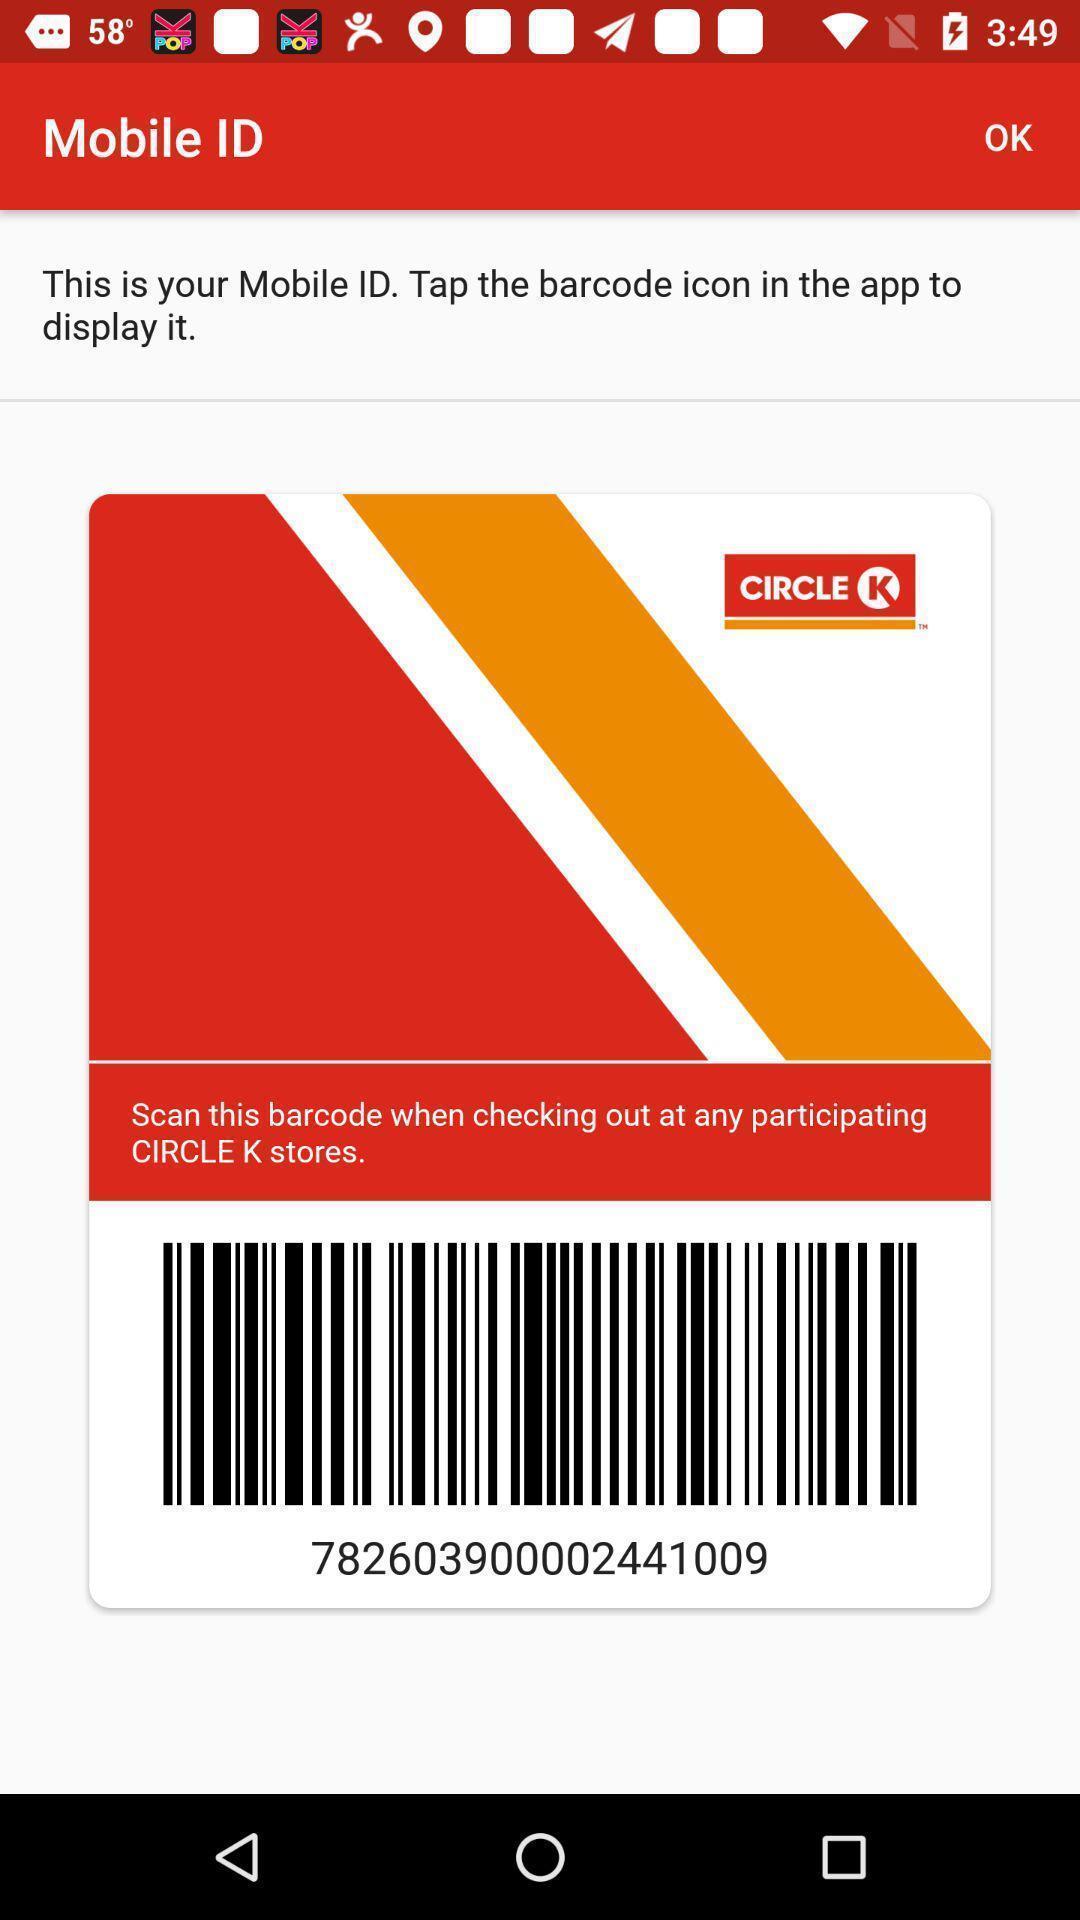Describe the content in this image. Screen shows barcode to display mobile id. 